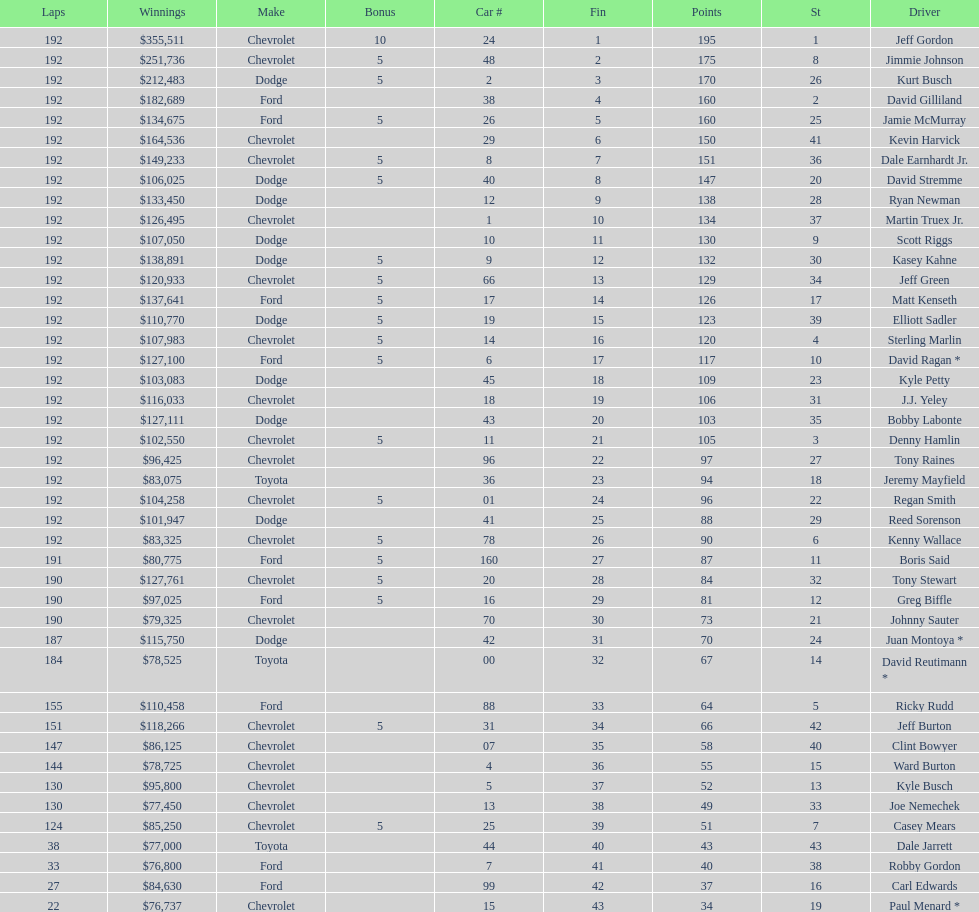Which make had the most consecutive finishes at the aarons 499? Chevrolet. 